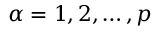<formula> <loc_0><loc_0><loc_500><loc_500>\alpha = 1 , 2 , \dots , p</formula> 